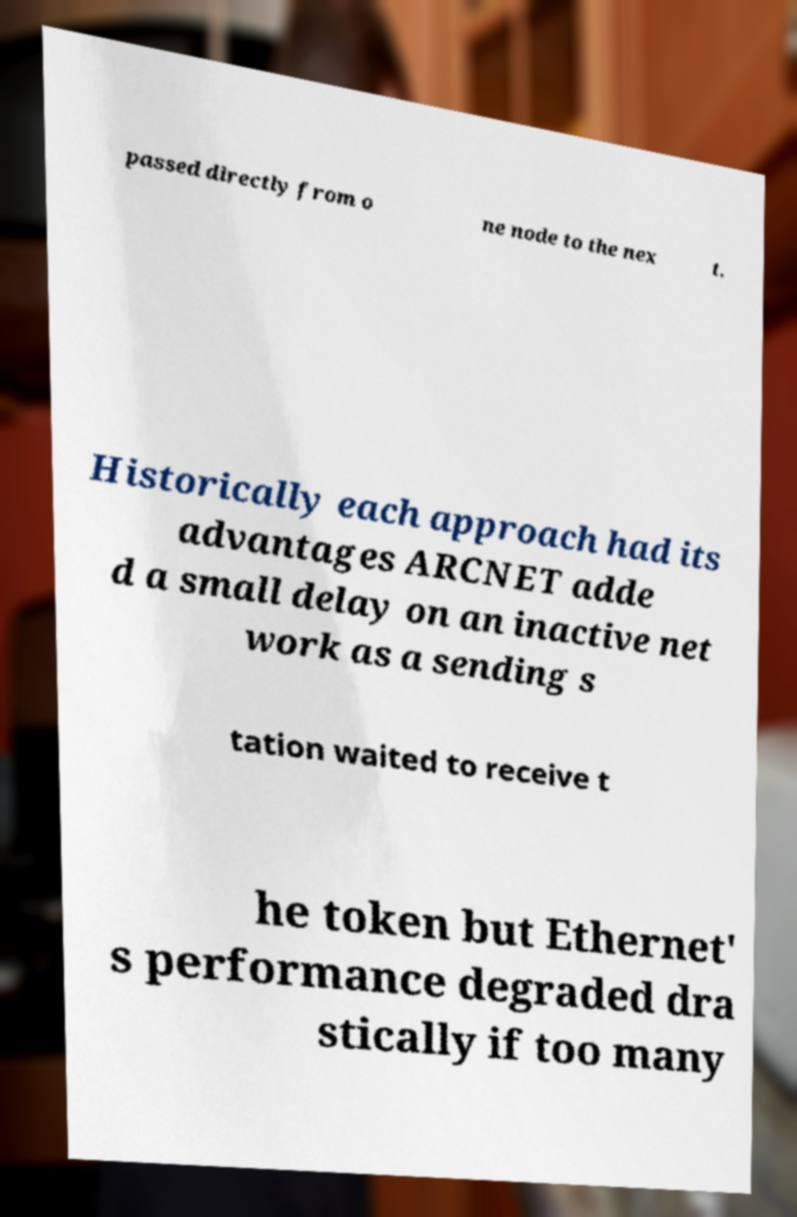Please read and relay the text visible in this image. What does it say? passed directly from o ne node to the nex t. Historically each approach had its advantages ARCNET adde d a small delay on an inactive net work as a sending s tation waited to receive t he token but Ethernet' s performance degraded dra stically if too many 